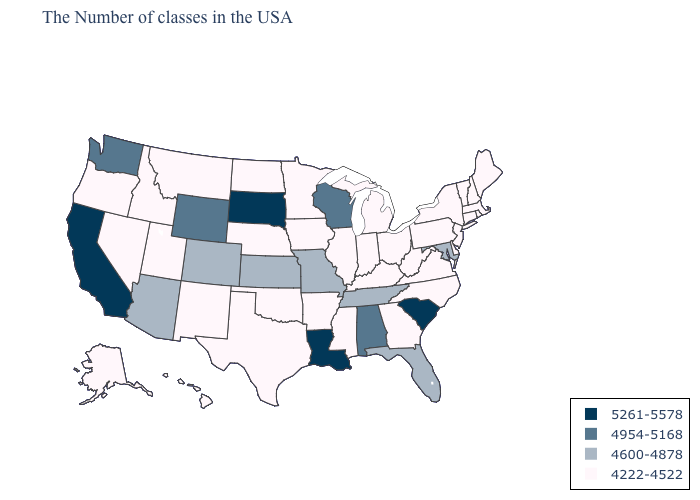What is the value of Kentucky?
Concise answer only. 4222-4522. Name the states that have a value in the range 4222-4522?
Keep it brief. Maine, Massachusetts, Rhode Island, New Hampshire, Vermont, Connecticut, New York, New Jersey, Delaware, Pennsylvania, Virginia, North Carolina, West Virginia, Ohio, Georgia, Michigan, Kentucky, Indiana, Illinois, Mississippi, Arkansas, Minnesota, Iowa, Nebraska, Oklahoma, Texas, North Dakota, New Mexico, Utah, Montana, Idaho, Nevada, Oregon, Alaska, Hawaii. What is the value of Minnesota?
Keep it brief. 4222-4522. Name the states that have a value in the range 4954-5168?
Write a very short answer. Alabama, Wisconsin, Wyoming, Washington. What is the value of North Dakota?
Quick response, please. 4222-4522. What is the value of Minnesota?
Keep it brief. 4222-4522. What is the value of Montana?
Concise answer only. 4222-4522. What is the value of Massachusetts?
Give a very brief answer. 4222-4522. Name the states that have a value in the range 4600-4878?
Short answer required. Maryland, Florida, Tennessee, Missouri, Kansas, Colorado, Arizona. What is the lowest value in states that border Texas?
Answer briefly. 4222-4522. Does the map have missing data?
Write a very short answer. No. Which states have the highest value in the USA?
Write a very short answer. South Carolina, Louisiana, South Dakota, California. Name the states that have a value in the range 4600-4878?
Give a very brief answer. Maryland, Florida, Tennessee, Missouri, Kansas, Colorado, Arizona. Does the first symbol in the legend represent the smallest category?
Give a very brief answer. No. Name the states that have a value in the range 4954-5168?
Concise answer only. Alabama, Wisconsin, Wyoming, Washington. 